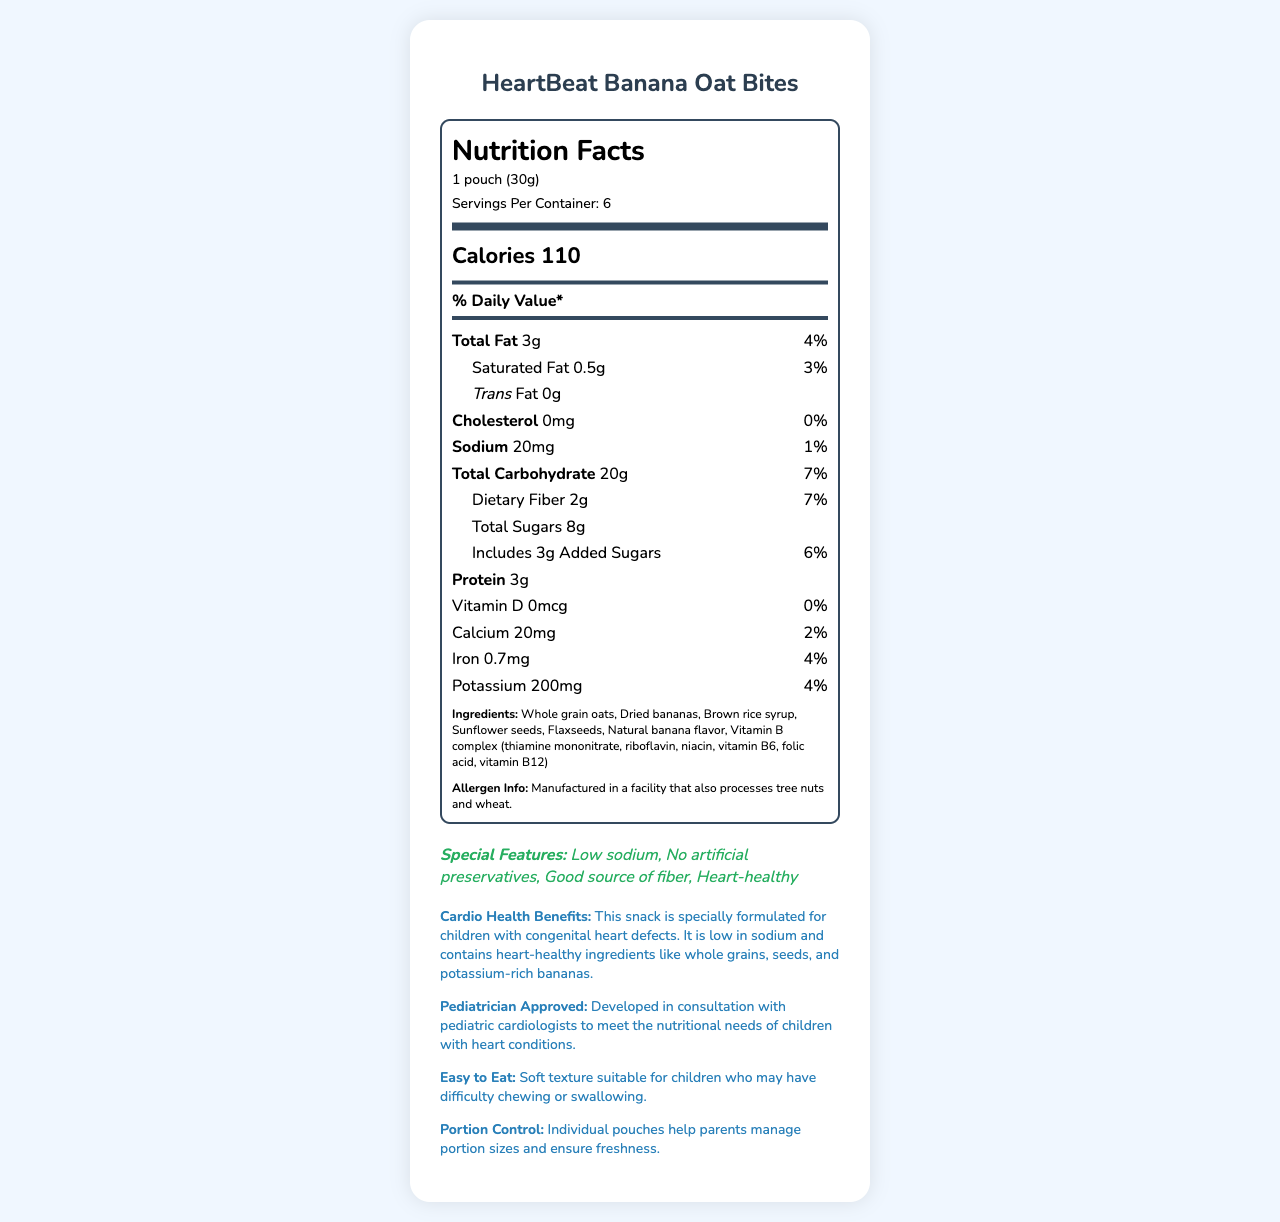what is the serving size of HeartBeat Banana Oat Bites? The serving size is clearly mentioned as "1 pouch (30g)" in the serving information section.
Answer: 1 pouch (30g) how many calories are in a serving? The calories per serving are specified as "Calories 110".
Answer: 110 how much sodium is in one serving? The amount of sodium per serving is stated as "Sodium 20mg".
Answer: 20mg which ingredient is the main source of fiber in this snack? Whole grain oats are listed first in the ingredients, indicating they are the main source, and the snack is noted as a good source of fiber.
Answer: Whole grain oats how much potassium is in one serving? The amount of potassium per serving is "Potassium 200mg".
Answer: 200mg what is the percentage daily value for total fat per serving? The percentage daily value for total fat per serving is "4%".
Answer: 4% what are the special features of this snack? A. Low sodium B. No artificial preservatives C. Good source of fiber D. Heart-healthy E. All of the above The special features section lists all of these attributes.
Answer: E how much added sugar does this snack contain? A. 2g B. 3g C. 4g D. 5g The amount of added sugars per serving is "Includes 3g Added Sugars".
Answer: B is this snack suitable for children with congenital heart defects? The additional information states that this snack is specially formulated for children with congenital heart defects and is developed in consultation with pediatric cardiologists.
Answer: Yes does the product contain any Vitamin D? The nutrition label shows Vitamin D as "0mcg" with a daily value of "0%".
Answer: No are HeartBeat Banana Oat Bites a good source of protein? With only 3g of protein per serving, they are not particularly highlighted as a protein-rich food.
Answer: No describe the main purpose and the key features of HeartBeat Banana Oat Bites. This description summarizes the main idea and key features of the product, highlighting both nutritional benefits and special considerations for children with heart conditions.
Answer: HeartBeat Banana Oat Bites are a heart-healthy snack formulated for children with congenital heart defects. They are low in sodium, contain no artificial preservatives, and are a good source of fiber. The product is developed in consultation with pediatric cardiologists and comes in portion-controlled pouches. what is the exact percentage daily value of dietary fiber per serving? The percentage daily value for dietary fiber is specified as "7%".
Answer: 7% why is this snack considered heart-healthy? The cardio health benefits section highlights these ingredients and their roles in heart health.
Answer: It is low in sodium and contains whole grains, flaxseeds, and potassium-rich bananas. where is this product manufactured? The document does not provide any specific details about the manufacturing location.
Answer: Not enough information is this product manufactured in a facility that processes tree nuts and wheat? The allergen information clearly states that the product is manufactured in a facility that also processes tree nuts and wheat.
Answer: Yes 